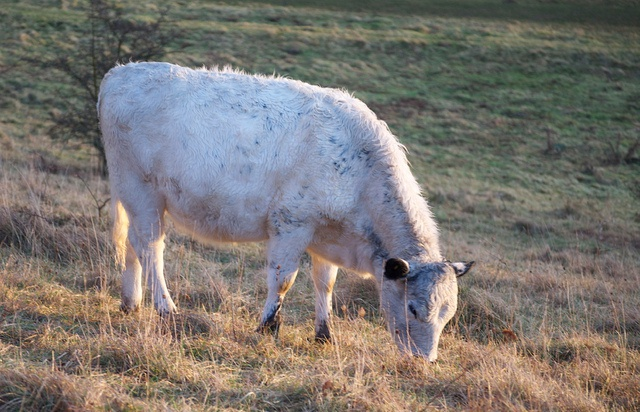Describe the objects in this image and their specific colors. I can see a cow in gray and darkgray tones in this image. 